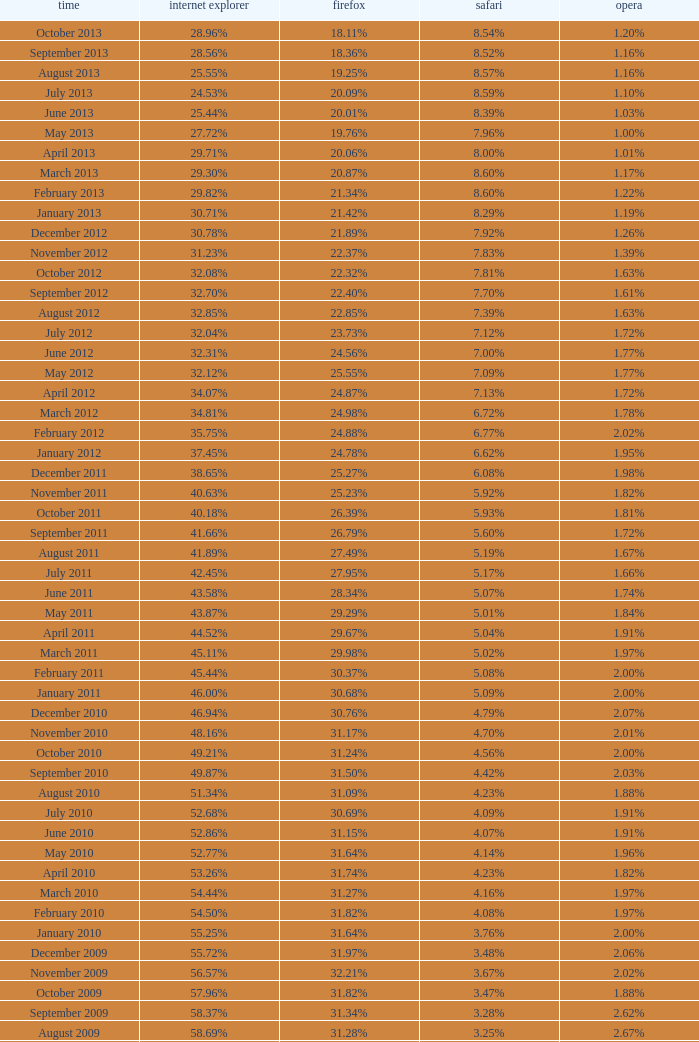What percentage of browsers were using Safari during the period in which 31.27% were using Firefox? 4.16%. 